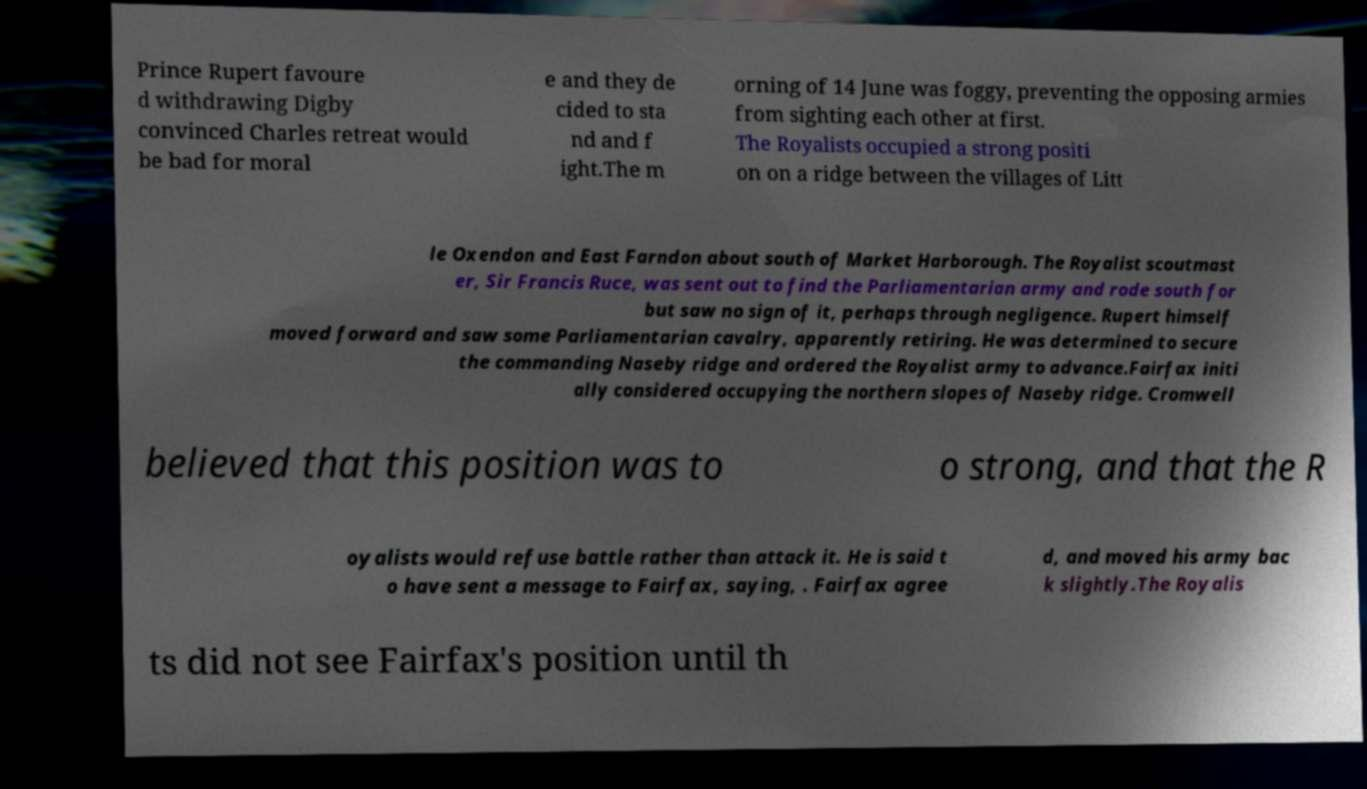Please read and relay the text visible in this image. What does it say? Prince Rupert favoure d withdrawing Digby convinced Charles retreat would be bad for moral e and they de cided to sta nd and f ight.The m orning of 14 June was foggy, preventing the opposing armies from sighting each other at first. The Royalists occupied a strong positi on on a ridge between the villages of Litt le Oxendon and East Farndon about south of Market Harborough. The Royalist scoutmast er, Sir Francis Ruce, was sent out to find the Parliamentarian army and rode south for but saw no sign of it, perhaps through negligence. Rupert himself moved forward and saw some Parliamentarian cavalry, apparently retiring. He was determined to secure the commanding Naseby ridge and ordered the Royalist army to advance.Fairfax initi ally considered occupying the northern slopes of Naseby ridge. Cromwell believed that this position was to o strong, and that the R oyalists would refuse battle rather than attack it. He is said t o have sent a message to Fairfax, saying, . Fairfax agree d, and moved his army bac k slightly.The Royalis ts did not see Fairfax's position until th 